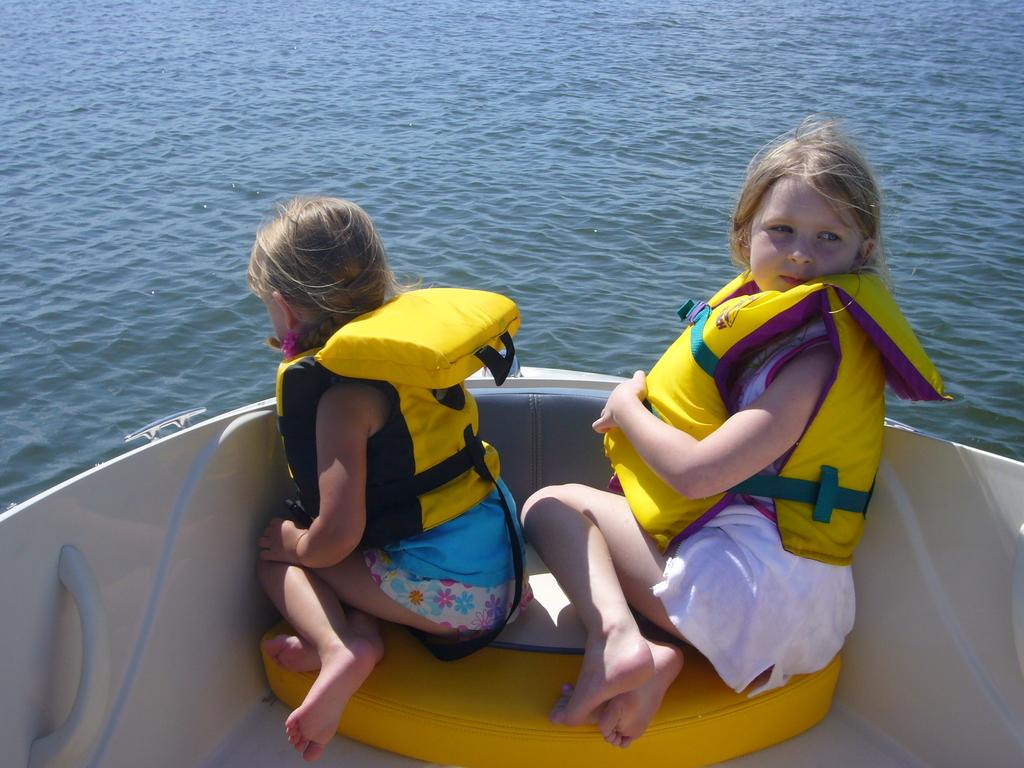How many people are in the image? There are two girls in the image. What are the girls wearing in the image? The girls are wearing swimming jackets in the image. Where are the girls sitting in the image? The girls are sitting on a platform on a boat in the image. What can be seen near the boat in the image? There is water visible near the boat in the image. What type of bread is being used as a part of the boat in the image? There is no bread present in the image, and bread is not a part of the boat. 